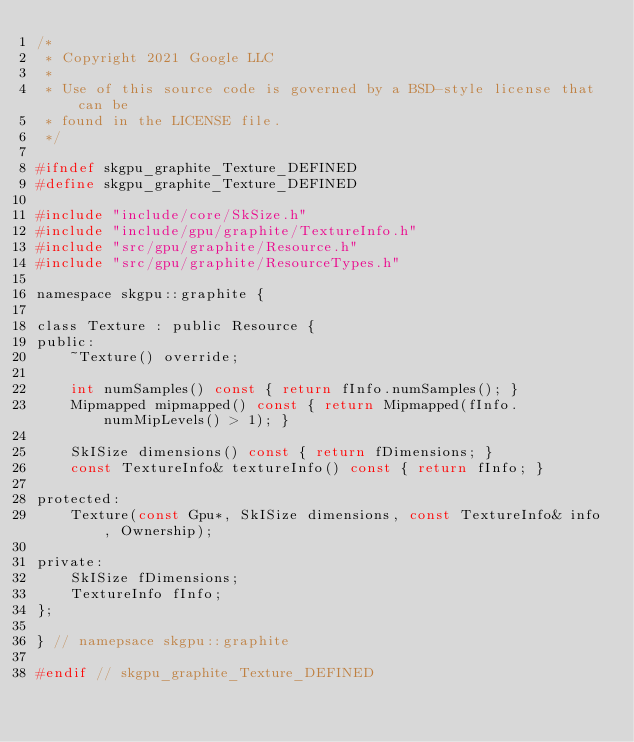Convert code to text. <code><loc_0><loc_0><loc_500><loc_500><_C_>/*
 * Copyright 2021 Google LLC
 *
 * Use of this source code is governed by a BSD-style license that can be
 * found in the LICENSE file.
 */

#ifndef skgpu_graphite_Texture_DEFINED
#define skgpu_graphite_Texture_DEFINED

#include "include/core/SkSize.h"
#include "include/gpu/graphite/TextureInfo.h"
#include "src/gpu/graphite/Resource.h"
#include "src/gpu/graphite/ResourceTypes.h"

namespace skgpu::graphite {

class Texture : public Resource {
public:
    ~Texture() override;

    int numSamples() const { return fInfo.numSamples(); }
    Mipmapped mipmapped() const { return Mipmapped(fInfo.numMipLevels() > 1); }

    SkISize dimensions() const { return fDimensions; }
    const TextureInfo& textureInfo() const { return fInfo; }

protected:
    Texture(const Gpu*, SkISize dimensions, const TextureInfo& info, Ownership);

private:
    SkISize fDimensions;
    TextureInfo fInfo;
};

} // namepsace skgpu::graphite

#endif // skgpu_graphite_Texture_DEFINED
</code> 